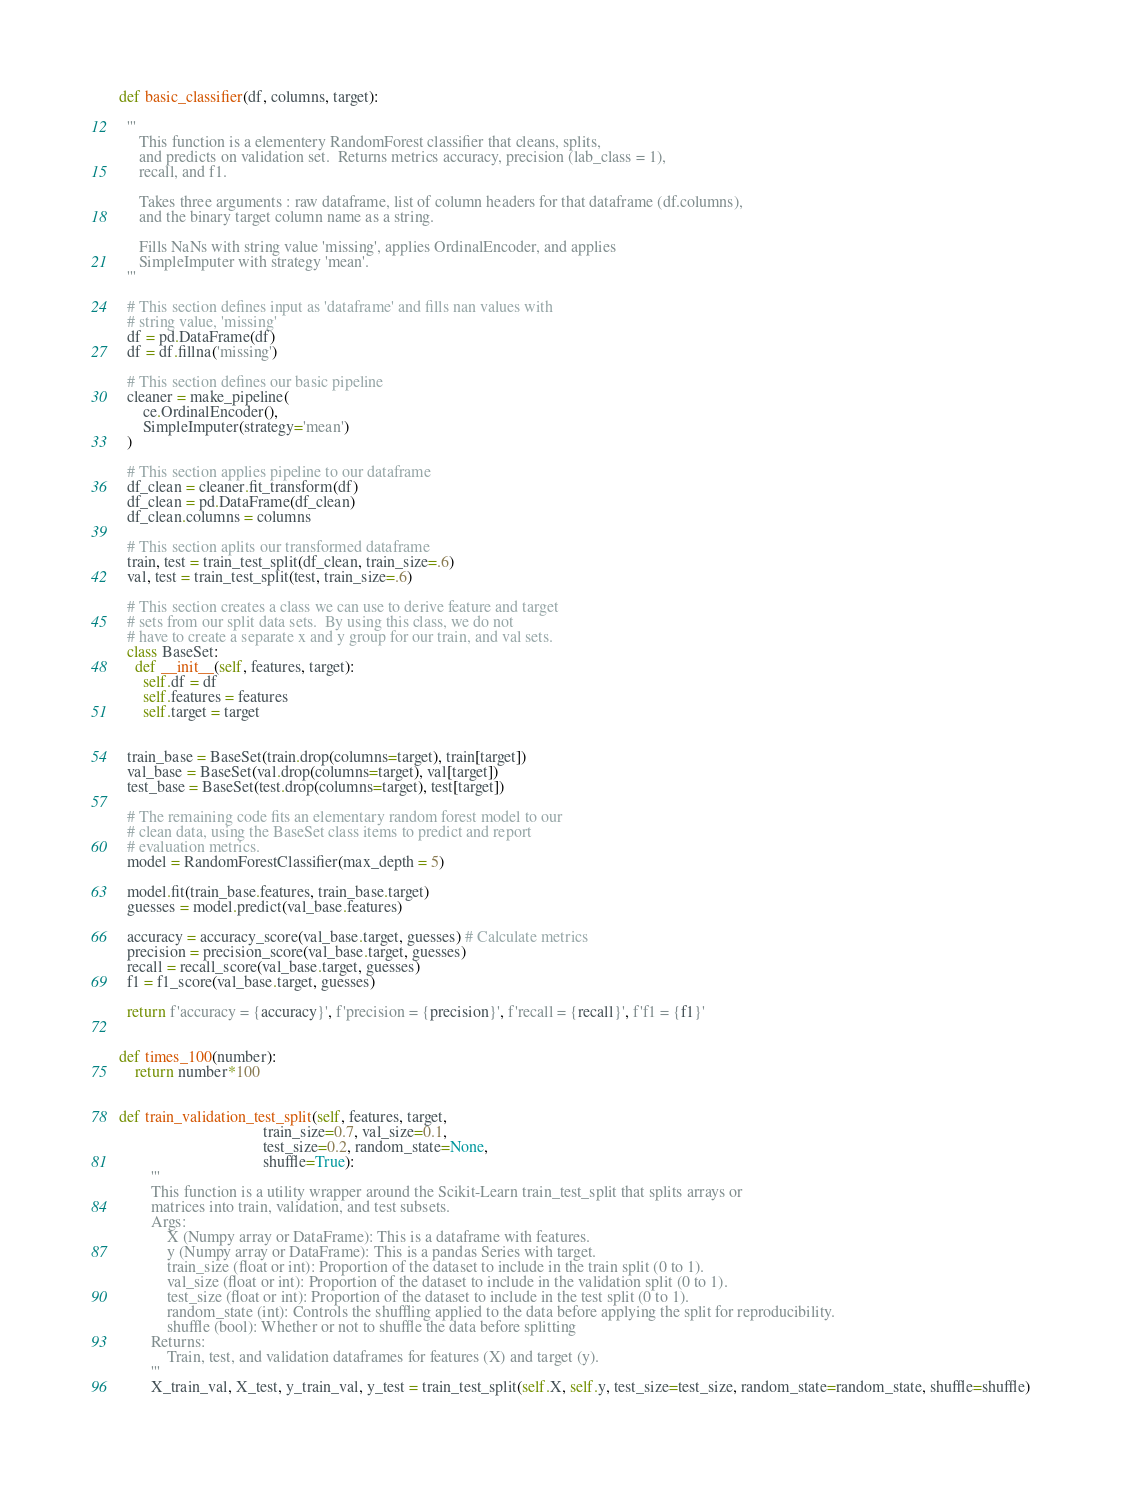<code> <loc_0><loc_0><loc_500><loc_500><_Python_>def basic_classifier(df, columns, target):

  '''
     This function is a elementery RandomForest classifier that cleans, splits,
     and predicts on validation set.  Returns metrics accuracy, precision (lab_class = 1),
     recall, and f1.
     
     Takes three arguments : raw dataframe, list of column headers for that dataframe (df.columns), 
     and the binary target column name as a string.

     Fills NaNs with string value 'missing', applies OrdinalEncoder, and applies
     SimpleImputer with strategy 'mean'.
  '''

  # This section defines input as 'dataframe' and fills nan values with
  # string value, 'missing'
  df = pd.DataFrame(df)  
  df = df.fillna('missing')

  # This section defines our basic pipeline
  cleaner = make_pipeline(   
      ce.OrdinalEncoder(),
      SimpleImputer(strategy='mean')
  )
  
  # This section applies pipeline to our dataframe
  df_clean = cleaner.fit_transform(df) 
  df_clean = pd.DataFrame(df_clean)
  df_clean.columns = columns

  # This section aplits our transformed dataframe
  train, test = train_test_split(df_clean, train_size=.6) 
  val, test = train_test_split(test, train_size=.6)
 
  # This section creates a class we can use to derive feature and target
  # sets from our split data sets.  By using this class, we do not
  # have to create a separate x and y group for our train, and val sets.
  class BaseSet:
    def __init__(self, features, target):
      self.df = df
      self.features = features
      self.target = target


  train_base = BaseSet(train.drop(columns=target), train[target])
  val_base = BaseSet(val.drop(columns=target), val[target])
  test_base = BaseSet(test.drop(columns=target), test[target])

  # The remaining code fits an elementary random forest model to our
  # clean data, using the BaseSet class items to predict and report
  # evaluation metrics.
  model = RandomForestClassifier(max_depth = 5)

  model.fit(train_base.features, train_base.target)
  guesses = model.predict(val_base.features)

  accuracy = accuracy_score(val_base.target, guesses) # Calculate metrics
  precision = precision_score(val_base.target, guesses)
  recall = recall_score(val_base.target, guesses)
  f1 = f1_score(val_base.target, guesses)

  return f'accuracy = {accuracy}', f'precision = {precision}', f'recall = {recall}', f'f1 = {f1}'


def times_100(number):
    return number*100
  

def train_validation_test_split(self, features, target,
                                    train_size=0.7, val_size=0.1,
                                    test_size=0.2, random_state=None,
                                    shuffle=True):
        '''
        This function is a utility wrapper around the Scikit-Learn train_test_split that splits arrays or 
        matrices into train, validation, and test subsets.
        Args:
            X (Numpy array or DataFrame): This is a dataframe with features.
            y (Numpy array or DataFrame): This is a pandas Series with target.
            train_size (float or int): Proportion of the dataset to include in the train split (0 to 1).
            val_size (float or int): Proportion of the dataset to include in the validation split (0 to 1).
            test_size (float or int): Proportion of the dataset to include in the test split (0 to 1).
            random_state (int): Controls the shuffling applied to the data before applying the split for reproducibility.
            shuffle (bool): Whether or not to shuffle the data before splitting
        Returns:
            Train, test, and validation dataframes for features (X) and target (y). 
        '''
        X_train_val, X_test, y_train_val, y_test = train_test_split(self.X, self.y, test_size=test_size, random_state=random_state, shuffle=shuffle)</code> 